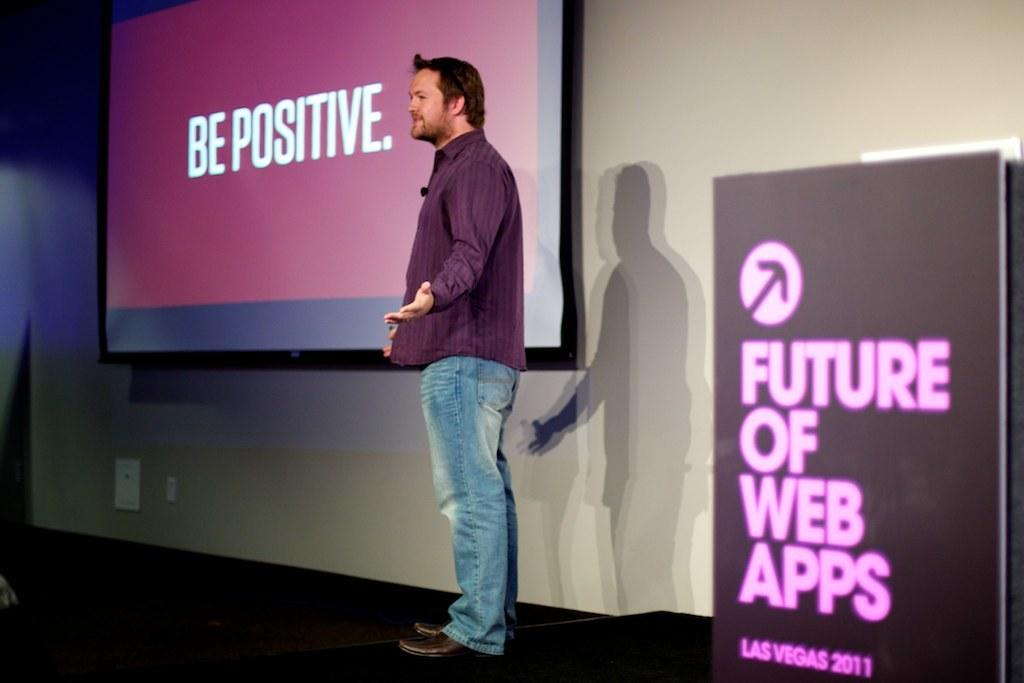What is the main subject in the center of the image? There is a person standing in the center of the image. What can be seen on the right side of the image? There is a banner on the right side of the image. What is located at the top of the image? There is a projector screen at the top of the image. What type of structure is visible at the top of the image? There is a wall visible at the top of the image. How much does the worm weigh in the image? There is no worm present in the image, so it is not possible to determine its weight. 